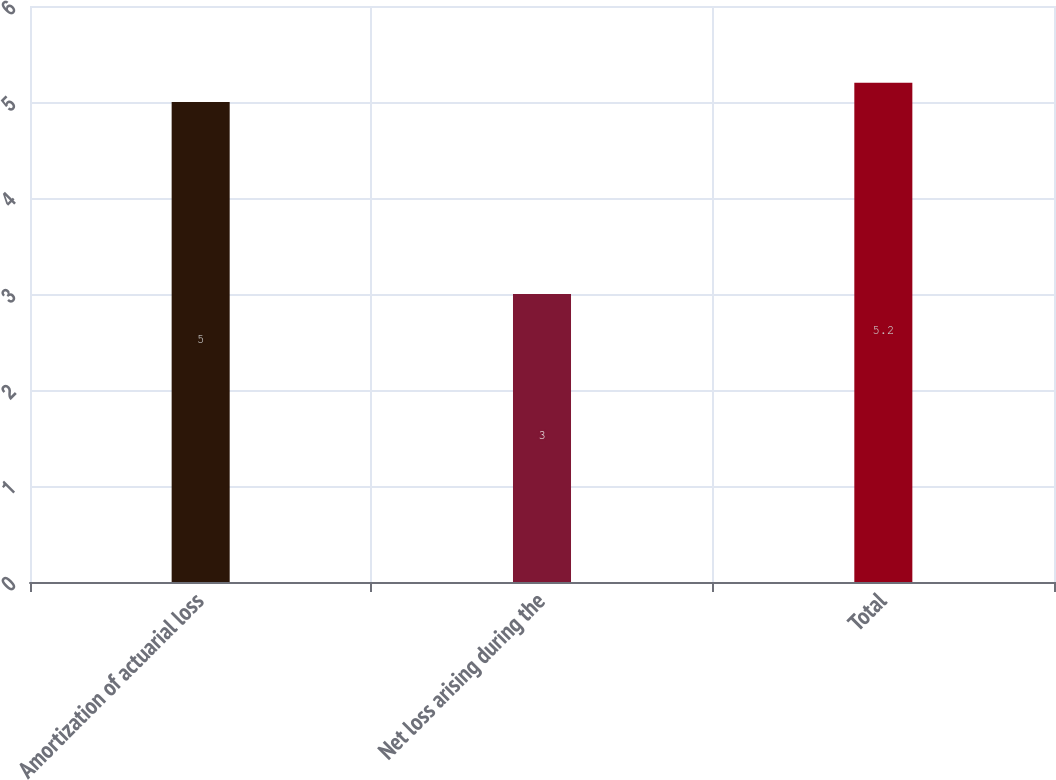Convert chart. <chart><loc_0><loc_0><loc_500><loc_500><bar_chart><fcel>Amortization of actuarial loss<fcel>Net loss arising during the<fcel>Total<nl><fcel>5<fcel>3<fcel>5.2<nl></chart> 